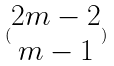Convert formula to latex. <formula><loc_0><loc_0><loc_500><loc_500>( \begin{matrix} 2 m - 2 \\ m - 1 \end{matrix} )</formula> 